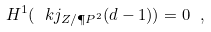Convert formula to latex. <formula><loc_0><loc_0><loc_500><loc_500>H ^ { 1 } ( \ k j _ { Z / \P P ^ { 2 } } ( d - 1 ) ) = 0 \ ,</formula> 